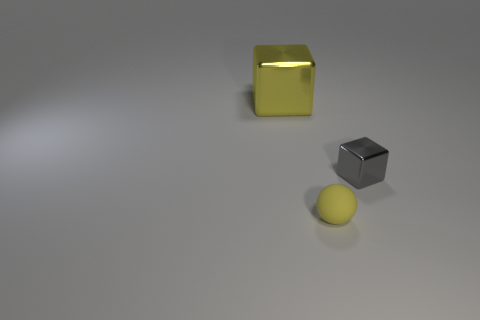Add 1 big objects. How many objects exist? 4 Subtract all yellow blocks. How many blocks are left? 1 Subtract all balls. How many objects are left? 2 Subtract 1 cubes. How many cubes are left? 1 Subtract all red cubes. Subtract all green cylinders. How many cubes are left? 2 Subtract all yellow balls. Subtract all small metal blocks. How many objects are left? 1 Add 2 big yellow objects. How many big yellow objects are left? 3 Add 2 big cyan matte cubes. How many big cyan matte cubes exist? 2 Subtract 0 cyan spheres. How many objects are left? 3 